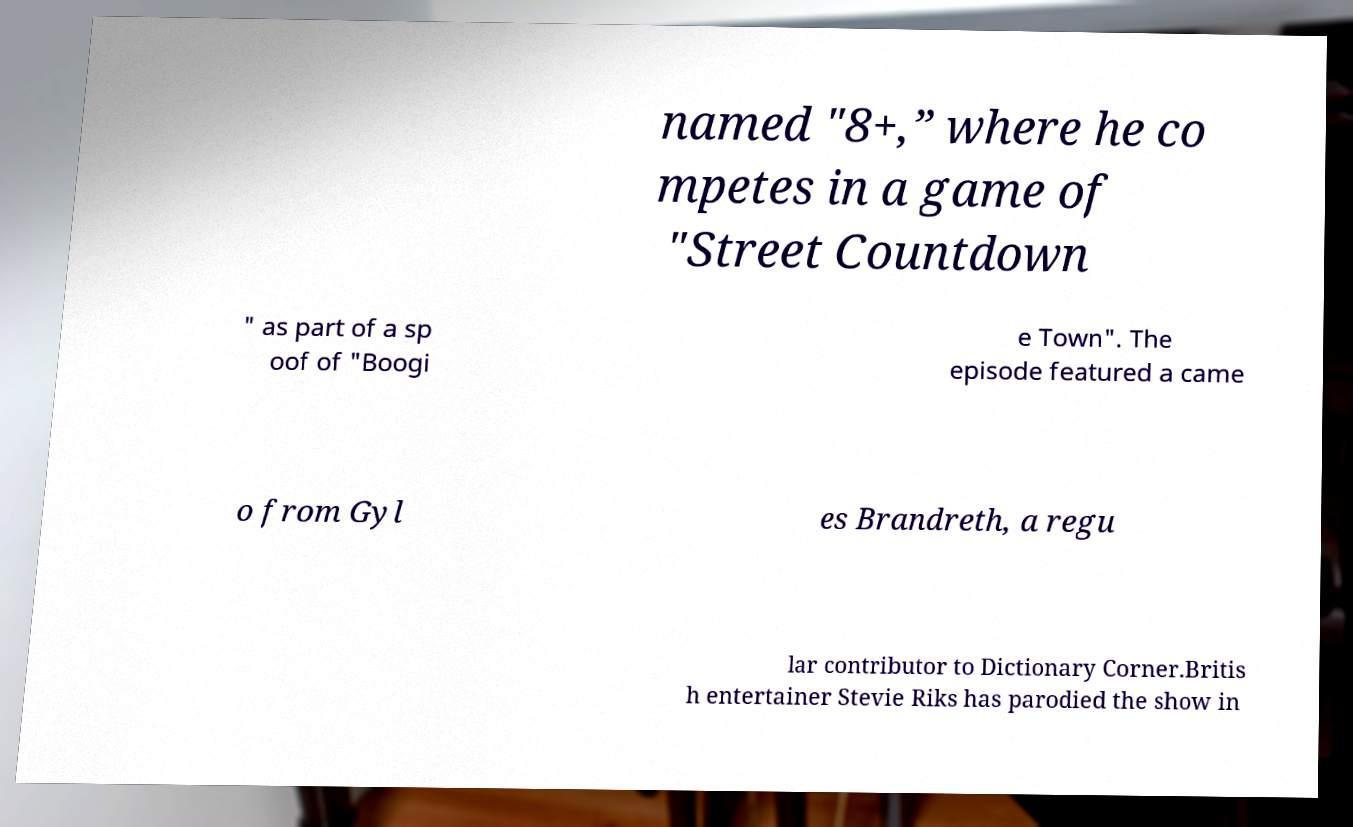What messages or text are displayed in this image? I need them in a readable, typed format. named "8+,” where he co mpetes in a game of "Street Countdown " as part of a sp oof of "Boogi e Town". The episode featured a came o from Gyl es Brandreth, a regu lar contributor to Dictionary Corner.Britis h entertainer Stevie Riks has parodied the show in 